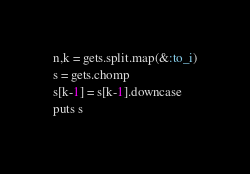<code> <loc_0><loc_0><loc_500><loc_500><_Ruby_>n,k = gets.split.map(&:to_i)
s = gets.chomp
s[k-1] = s[k-1].downcase
puts s
</code> 